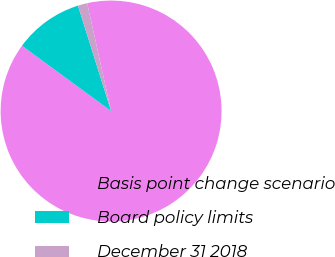<chart> <loc_0><loc_0><loc_500><loc_500><pie_chart><fcel>Basis point change scenario<fcel>Board policy limits<fcel>December 31 2018<nl><fcel>88.54%<fcel>10.09%<fcel>1.37%<nl></chart> 